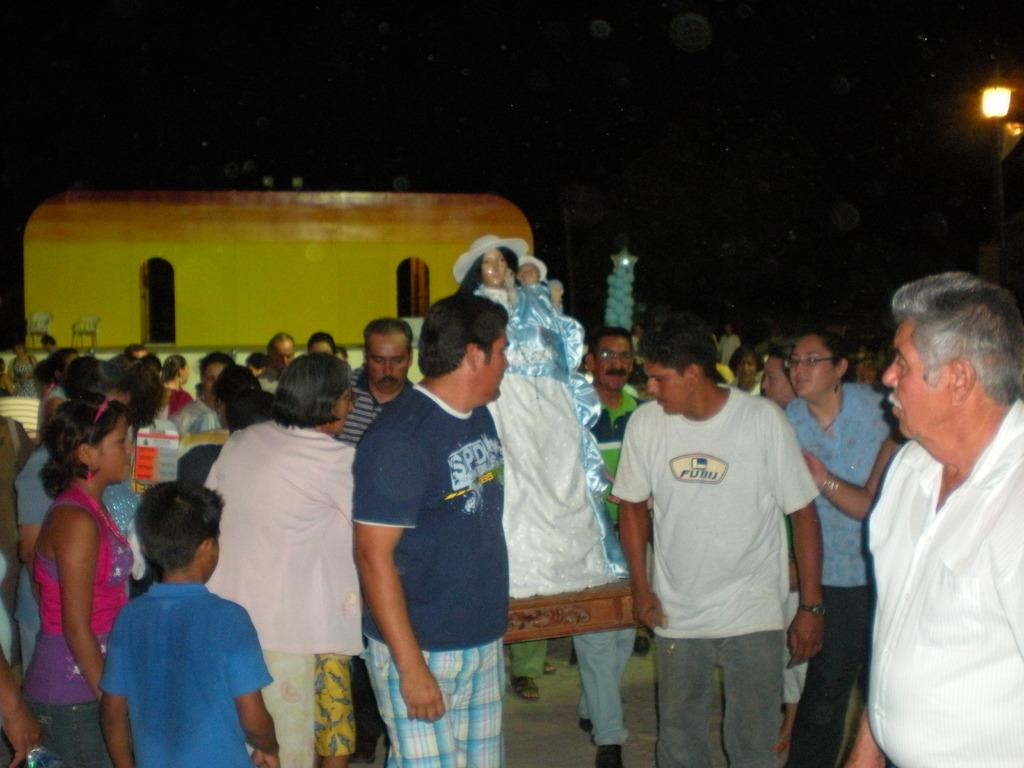How many people are in the image? There is a group of people in the image. What are the people in the image doing? Some people are standing, while others are walking. What can be seen under the people's feet in the image? The ground is visible in the image. What is present in the background of the image? There is a light and chairs in the background of the image. How would you describe the lighting in the image? The image appears to be dark. What type of parcel is being carried by the person wearing a skirt in the image? There is no person wearing a skirt or carrying a parcel in the image. What is the drain used for in the image? There is no drain present in the image. 